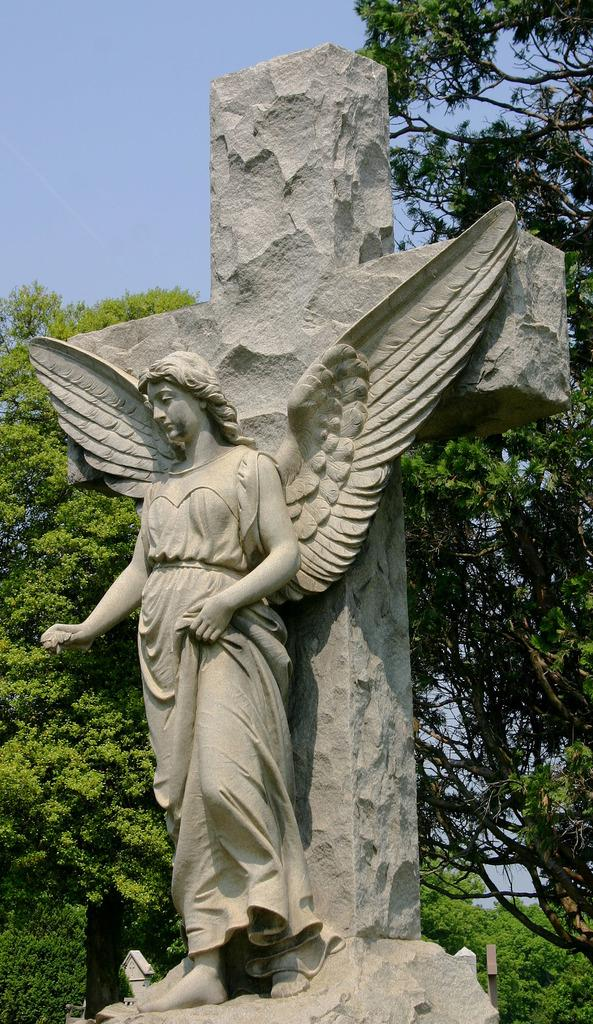What is the main subject of the image? There is a statue of a person with wings in the image. Can you describe the appearance of the statue? The statue is in ash color. What can be seen in the background of the image? There are many trees and the sky visible in the background of the image. How many birds are flying around the statue in the image? There are no birds present in the image. Can you describe the statue's movement in the image? The statue is stationary in the image and does not move. 